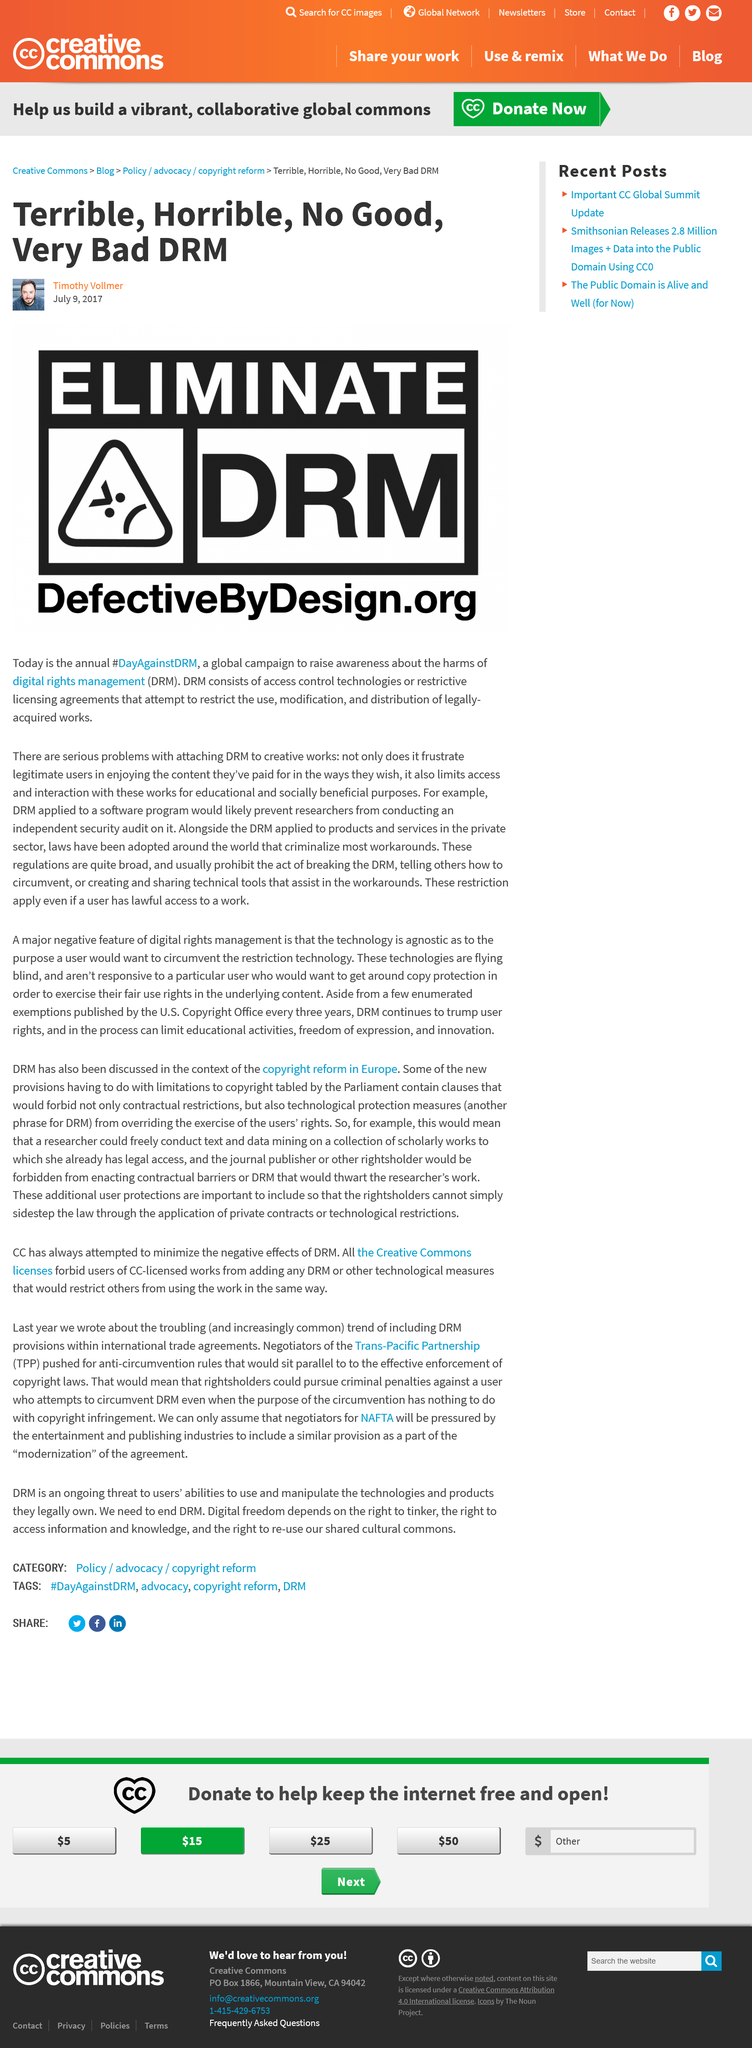Give some essential details in this illustration. The surname of the author of the article is Vollmer. The website of the anti-DRM campaign is called 'Defective by Design'. Digital rights management, abbreviated DRM, is the three-letter term used throughout the article. 